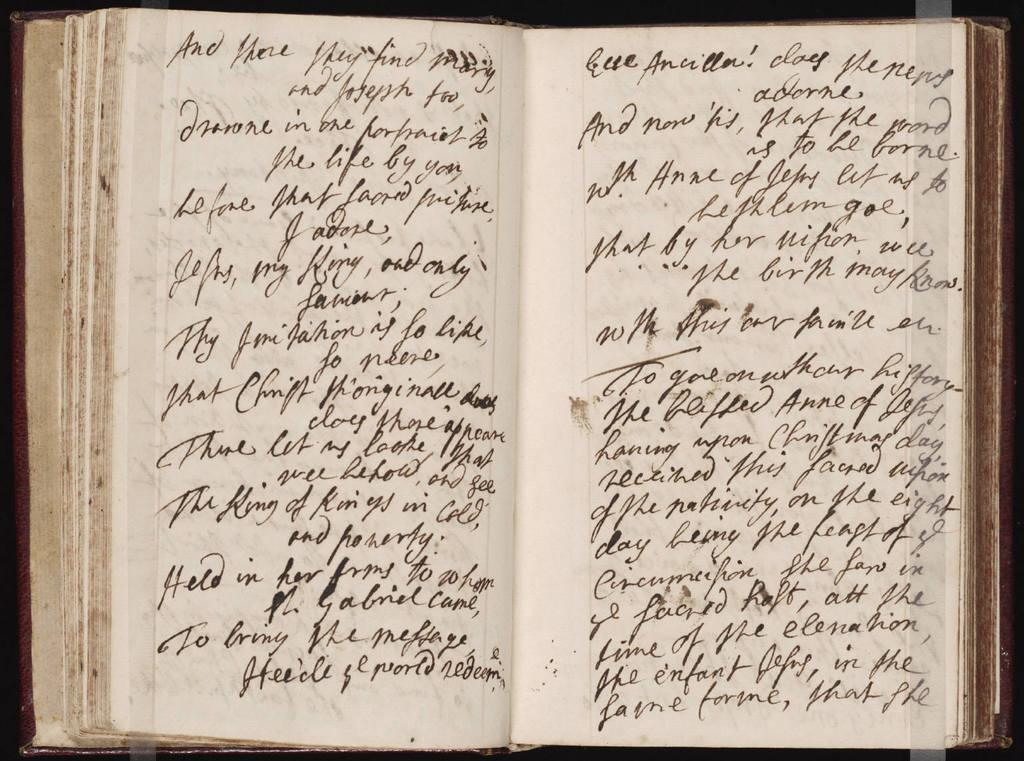What object can be seen in the image? There is a book in the image. What is written on the book? The book has text written on it. Can you see a deer flying in the image? No, there is no deer or any flying object present in the image. 